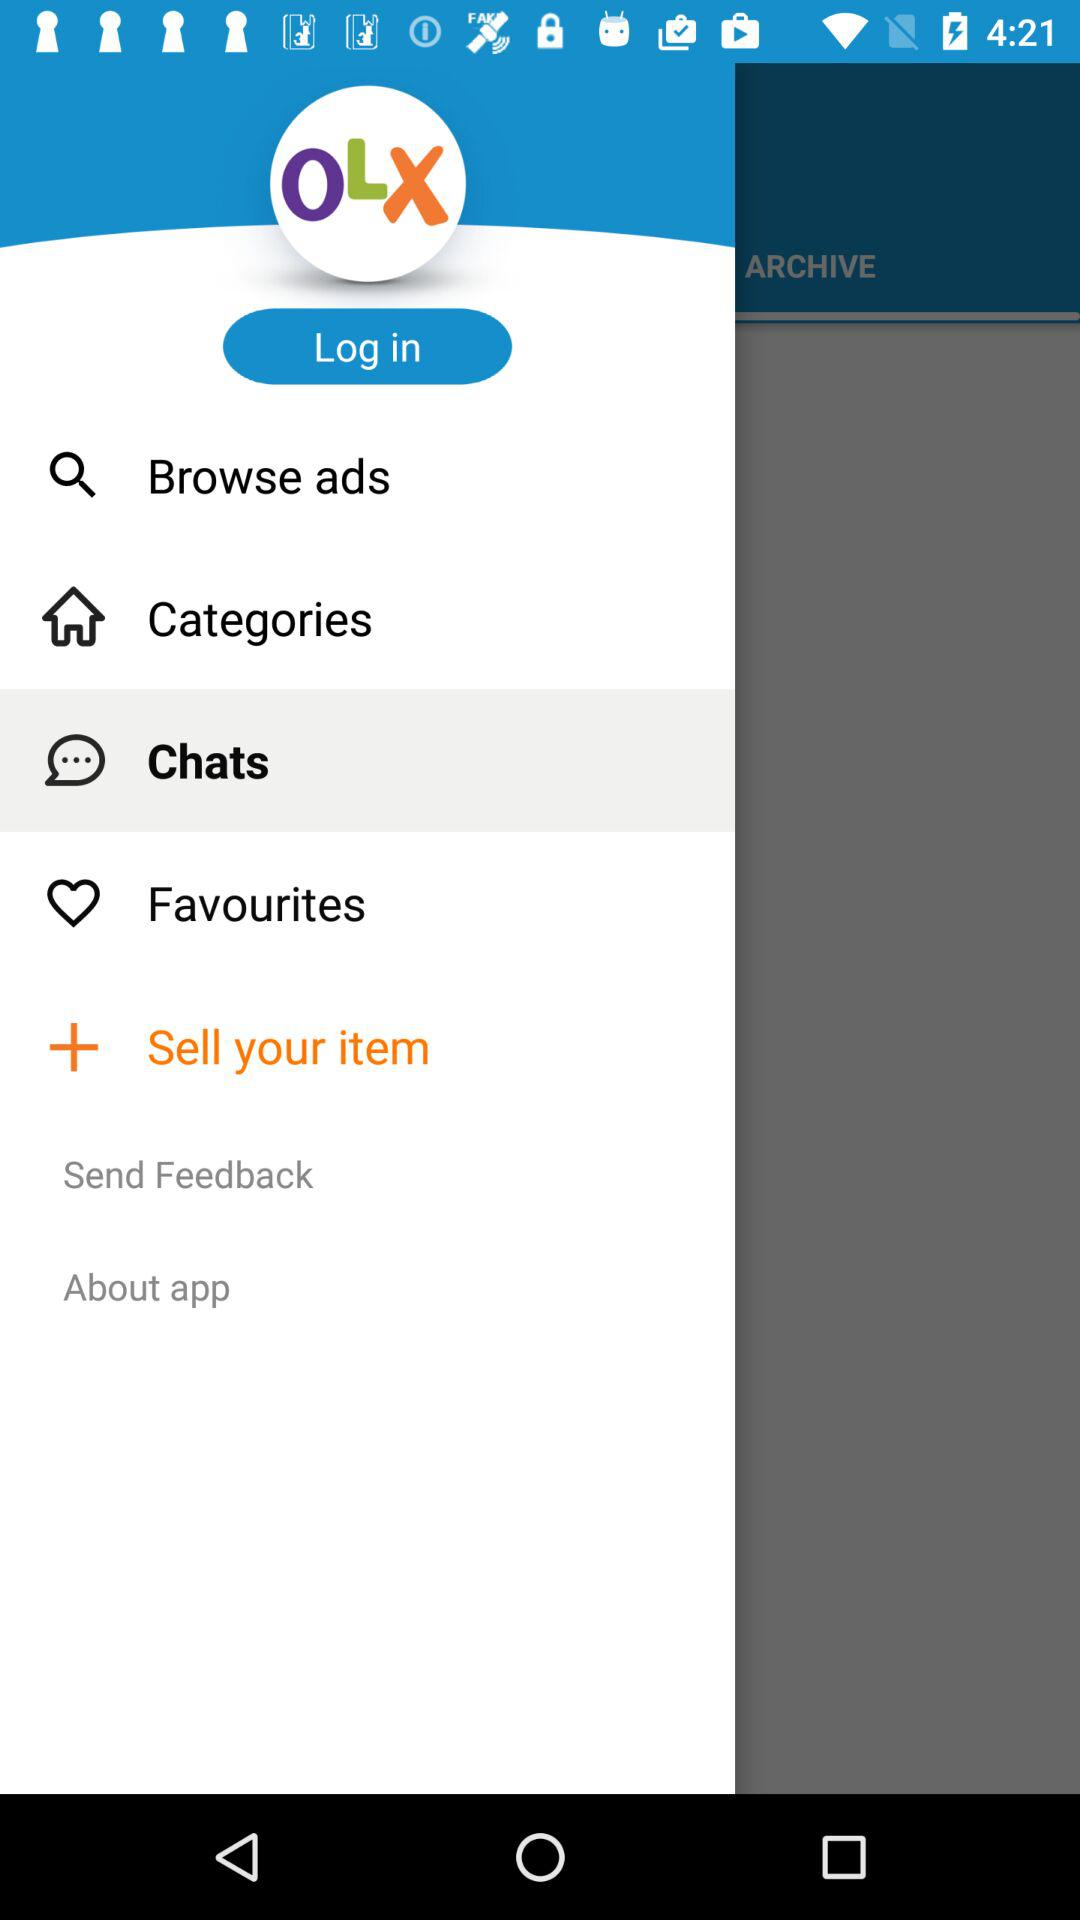How many items are in the menu?
Answer the question using a single word or phrase. 7 